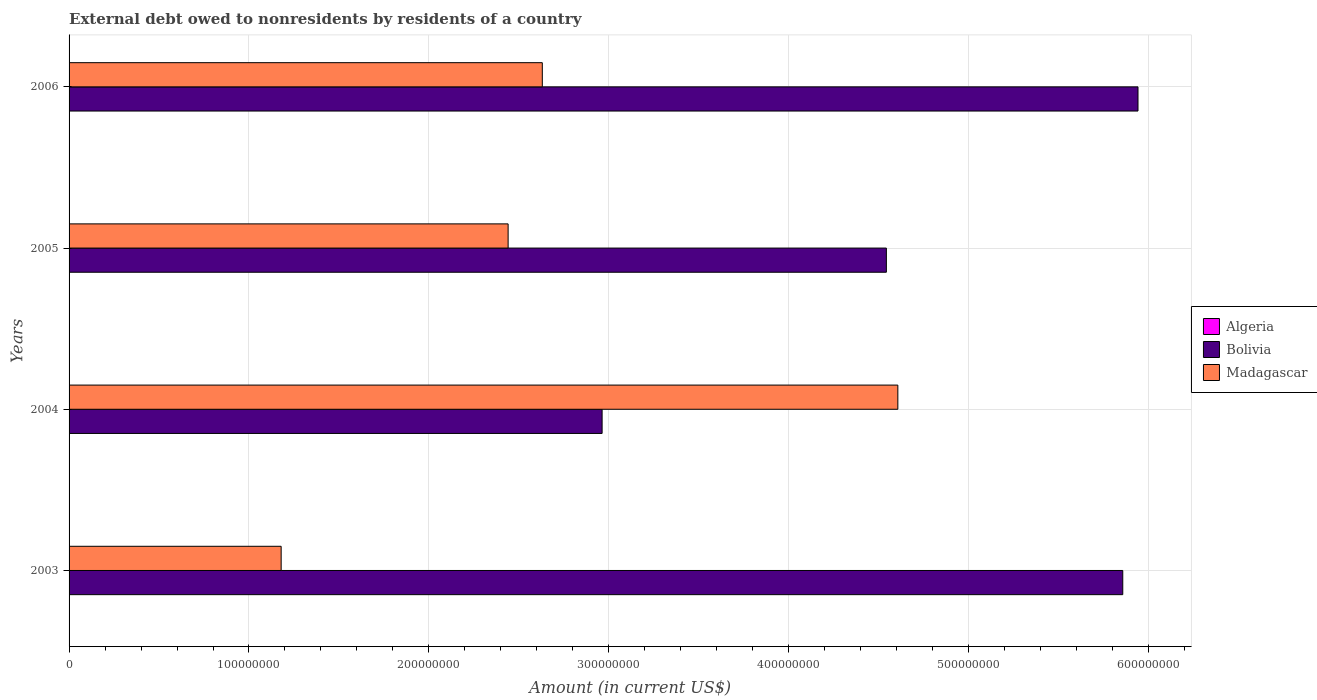How many bars are there on the 4th tick from the top?
Provide a succinct answer. 2. What is the label of the 4th group of bars from the top?
Ensure brevity in your answer.  2003. In how many cases, is the number of bars for a given year not equal to the number of legend labels?
Offer a terse response. 4. What is the external debt owed by residents in Madagascar in 2004?
Offer a terse response. 4.61e+08. Across all years, what is the minimum external debt owed by residents in Madagascar?
Your response must be concise. 1.18e+08. What is the total external debt owed by residents in Bolivia in the graph?
Your answer should be very brief. 1.93e+09. What is the difference between the external debt owed by residents in Madagascar in 2005 and that in 2006?
Provide a succinct answer. -1.90e+07. What is the difference between the external debt owed by residents in Bolivia in 2004 and the external debt owed by residents in Madagascar in 2003?
Your response must be concise. 1.78e+08. What is the average external debt owed by residents in Bolivia per year?
Offer a terse response. 4.83e+08. In the year 2005, what is the difference between the external debt owed by residents in Madagascar and external debt owed by residents in Bolivia?
Keep it short and to the point. -2.10e+08. What is the ratio of the external debt owed by residents in Bolivia in 2003 to that in 2005?
Offer a terse response. 1.29. What is the difference between the highest and the second highest external debt owed by residents in Bolivia?
Make the answer very short. 8.47e+06. What is the difference between the highest and the lowest external debt owed by residents in Madagascar?
Offer a terse response. 3.43e+08. In how many years, is the external debt owed by residents in Algeria greater than the average external debt owed by residents in Algeria taken over all years?
Provide a short and direct response. 0. Is it the case that in every year, the sum of the external debt owed by residents in Algeria and external debt owed by residents in Madagascar is greater than the external debt owed by residents in Bolivia?
Your response must be concise. No. How many bars are there?
Make the answer very short. 8. Are all the bars in the graph horizontal?
Your response must be concise. Yes. How many years are there in the graph?
Keep it short and to the point. 4. What is the difference between two consecutive major ticks on the X-axis?
Your response must be concise. 1.00e+08. Are the values on the major ticks of X-axis written in scientific E-notation?
Make the answer very short. No. Does the graph contain grids?
Make the answer very short. Yes. What is the title of the graph?
Your answer should be compact. External debt owed to nonresidents by residents of a country. Does "Bangladesh" appear as one of the legend labels in the graph?
Ensure brevity in your answer.  No. What is the label or title of the X-axis?
Your response must be concise. Amount (in current US$). What is the label or title of the Y-axis?
Offer a terse response. Years. What is the Amount (in current US$) of Algeria in 2003?
Your answer should be compact. 0. What is the Amount (in current US$) of Bolivia in 2003?
Provide a short and direct response. 5.86e+08. What is the Amount (in current US$) of Madagascar in 2003?
Keep it short and to the point. 1.18e+08. What is the Amount (in current US$) in Bolivia in 2004?
Ensure brevity in your answer.  2.96e+08. What is the Amount (in current US$) of Madagascar in 2004?
Your response must be concise. 4.61e+08. What is the Amount (in current US$) of Bolivia in 2005?
Offer a very short reply. 4.54e+08. What is the Amount (in current US$) in Madagascar in 2005?
Your response must be concise. 2.44e+08. What is the Amount (in current US$) in Bolivia in 2006?
Give a very brief answer. 5.94e+08. What is the Amount (in current US$) of Madagascar in 2006?
Give a very brief answer. 2.63e+08. Across all years, what is the maximum Amount (in current US$) in Bolivia?
Give a very brief answer. 5.94e+08. Across all years, what is the maximum Amount (in current US$) in Madagascar?
Offer a very short reply. 4.61e+08. Across all years, what is the minimum Amount (in current US$) in Bolivia?
Offer a very short reply. 2.96e+08. Across all years, what is the minimum Amount (in current US$) of Madagascar?
Ensure brevity in your answer.  1.18e+08. What is the total Amount (in current US$) in Bolivia in the graph?
Provide a short and direct response. 1.93e+09. What is the total Amount (in current US$) of Madagascar in the graph?
Give a very brief answer. 1.09e+09. What is the difference between the Amount (in current US$) in Bolivia in 2003 and that in 2004?
Make the answer very short. 2.89e+08. What is the difference between the Amount (in current US$) in Madagascar in 2003 and that in 2004?
Offer a very short reply. -3.43e+08. What is the difference between the Amount (in current US$) in Bolivia in 2003 and that in 2005?
Offer a terse response. 1.31e+08. What is the difference between the Amount (in current US$) of Madagascar in 2003 and that in 2005?
Give a very brief answer. -1.26e+08. What is the difference between the Amount (in current US$) of Bolivia in 2003 and that in 2006?
Your answer should be compact. -8.47e+06. What is the difference between the Amount (in current US$) of Madagascar in 2003 and that in 2006?
Keep it short and to the point. -1.45e+08. What is the difference between the Amount (in current US$) in Bolivia in 2004 and that in 2005?
Make the answer very short. -1.58e+08. What is the difference between the Amount (in current US$) in Madagascar in 2004 and that in 2005?
Ensure brevity in your answer.  2.17e+08. What is the difference between the Amount (in current US$) of Bolivia in 2004 and that in 2006?
Provide a short and direct response. -2.98e+08. What is the difference between the Amount (in current US$) of Madagascar in 2004 and that in 2006?
Ensure brevity in your answer.  1.98e+08. What is the difference between the Amount (in current US$) in Bolivia in 2005 and that in 2006?
Ensure brevity in your answer.  -1.40e+08. What is the difference between the Amount (in current US$) in Madagascar in 2005 and that in 2006?
Your response must be concise. -1.90e+07. What is the difference between the Amount (in current US$) in Bolivia in 2003 and the Amount (in current US$) in Madagascar in 2004?
Provide a short and direct response. 1.25e+08. What is the difference between the Amount (in current US$) of Bolivia in 2003 and the Amount (in current US$) of Madagascar in 2005?
Offer a very short reply. 3.42e+08. What is the difference between the Amount (in current US$) of Bolivia in 2003 and the Amount (in current US$) of Madagascar in 2006?
Provide a succinct answer. 3.23e+08. What is the difference between the Amount (in current US$) of Bolivia in 2004 and the Amount (in current US$) of Madagascar in 2005?
Make the answer very short. 5.22e+07. What is the difference between the Amount (in current US$) in Bolivia in 2004 and the Amount (in current US$) in Madagascar in 2006?
Offer a terse response. 3.32e+07. What is the difference between the Amount (in current US$) in Bolivia in 2005 and the Amount (in current US$) in Madagascar in 2006?
Offer a very short reply. 1.91e+08. What is the average Amount (in current US$) in Bolivia per year?
Offer a very short reply. 4.83e+08. What is the average Amount (in current US$) in Madagascar per year?
Your answer should be compact. 2.71e+08. In the year 2003, what is the difference between the Amount (in current US$) of Bolivia and Amount (in current US$) of Madagascar?
Ensure brevity in your answer.  4.68e+08. In the year 2004, what is the difference between the Amount (in current US$) in Bolivia and Amount (in current US$) in Madagascar?
Your answer should be compact. -1.64e+08. In the year 2005, what is the difference between the Amount (in current US$) of Bolivia and Amount (in current US$) of Madagascar?
Give a very brief answer. 2.10e+08. In the year 2006, what is the difference between the Amount (in current US$) in Bolivia and Amount (in current US$) in Madagascar?
Provide a succinct answer. 3.31e+08. What is the ratio of the Amount (in current US$) in Bolivia in 2003 to that in 2004?
Offer a terse response. 1.98. What is the ratio of the Amount (in current US$) in Madagascar in 2003 to that in 2004?
Provide a short and direct response. 0.26. What is the ratio of the Amount (in current US$) in Bolivia in 2003 to that in 2005?
Provide a succinct answer. 1.29. What is the ratio of the Amount (in current US$) in Madagascar in 2003 to that in 2005?
Offer a terse response. 0.48. What is the ratio of the Amount (in current US$) of Bolivia in 2003 to that in 2006?
Make the answer very short. 0.99. What is the ratio of the Amount (in current US$) in Madagascar in 2003 to that in 2006?
Provide a short and direct response. 0.45. What is the ratio of the Amount (in current US$) in Bolivia in 2004 to that in 2005?
Your response must be concise. 0.65. What is the ratio of the Amount (in current US$) of Madagascar in 2004 to that in 2005?
Offer a very short reply. 1.89. What is the ratio of the Amount (in current US$) in Bolivia in 2004 to that in 2006?
Your response must be concise. 0.5. What is the ratio of the Amount (in current US$) of Madagascar in 2004 to that in 2006?
Your answer should be compact. 1.75. What is the ratio of the Amount (in current US$) in Bolivia in 2005 to that in 2006?
Offer a very short reply. 0.76. What is the ratio of the Amount (in current US$) of Madagascar in 2005 to that in 2006?
Offer a terse response. 0.93. What is the difference between the highest and the second highest Amount (in current US$) in Bolivia?
Provide a succinct answer. 8.47e+06. What is the difference between the highest and the second highest Amount (in current US$) of Madagascar?
Offer a terse response. 1.98e+08. What is the difference between the highest and the lowest Amount (in current US$) in Bolivia?
Ensure brevity in your answer.  2.98e+08. What is the difference between the highest and the lowest Amount (in current US$) in Madagascar?
Ensure brevity in your answer.  3.43e+08. 